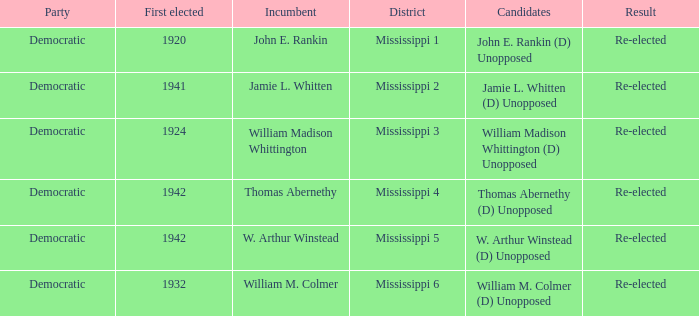Which district is jamie l. whitten from? Mississippi 2. 